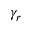<formula> <loc_0><loc_0><loc_500><loc_500>\gamma _ { r }</formula> 